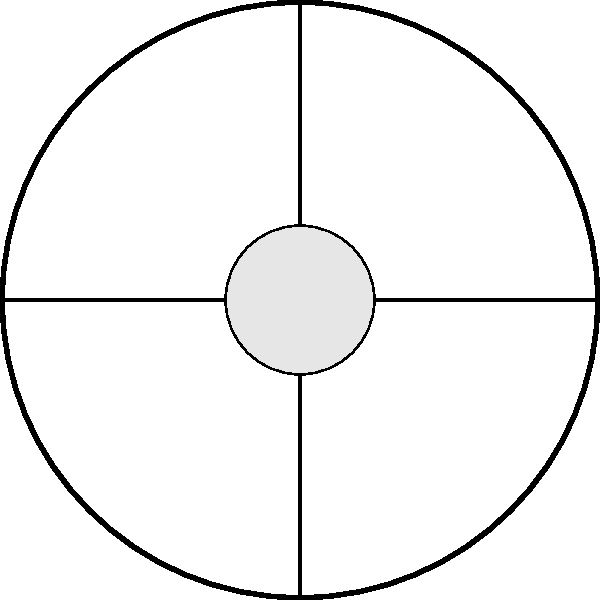Based on the layout of this typical Eastern Wu kingdom city, which statement is most accurate regarding the positioning of key elements?
A) The market is located in the northeast quadrant
B) The palace is situated at the city's edge
C) Residential areas are evenly distributed around the center
D) The main streets form a perfect grid pattern Let's analyze the city layout step-by-step:

1. City structure: The city is enclosed by a circular wall, typical of many ancient Chinese cities.

2. Palace: Located at the center of the city, represented by the larger circle. This central position symbolizes the importance and power of the ruling class.

3. Main streets: Two main streets intersect at the center, dividing the city into four quadrants. This is a common feature in ancient Chinese urban planning, known as the "jing-shi" (well-field) system.

4. Market: Positioned in the southwest quadrant, represented by the square shape. Markets were often placed away from the central areas to separate commerce from administration.

5. Residential areas: Smaller circles are distributed around the central palace, occupying the remaining space within the city walls. This represents the living quarters for the general population.

6. Orientation: The city is oriented with cardinal directions marked (N, S, E, W).

Analyzing the given options:
A) Incorrect: The market is in the southwest, not northeast.
B) Incorrect: The palace is at the center, not the edge.
C) Correct: Residential areas are indeed evenly distributed around the center.
D) Incorrect: While there are two main intersecting streets, they don't form a perfect grid pattern throughout the city.

Therefore, the most accurate statement is C: Residential areas are evenly distributed around the center.
Answer: C) Residential areas are evenly distributed around the center 